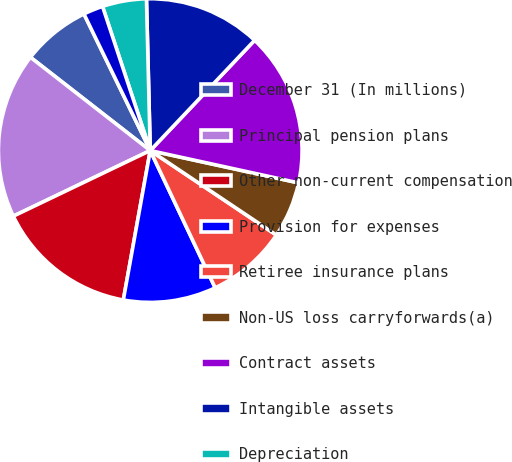<chart> <loc_0><loc_0><loc_500><loc_500><pie_chart><fcel>December 31 (In millions)<fcel>Principal pension plans<fcel>Other non-current compensation<fcel>Provision for expenses<fcel>Retiree insurance plans<fcel>Non-US loss carryforwards(a)<fcel>Contract assets<fcel>Intangible assets<fcel>Depreciation<fcel>Investment in global<nl><fcel>7.28%<fcel>17.64%<fcel>15.05%<fcel>9.87%<fcel>8.57%<fcel>5.98%<fcel>16.35%<fcel>12.46%<fcel>4.69%<fcel>2.1%<nl></chart> 